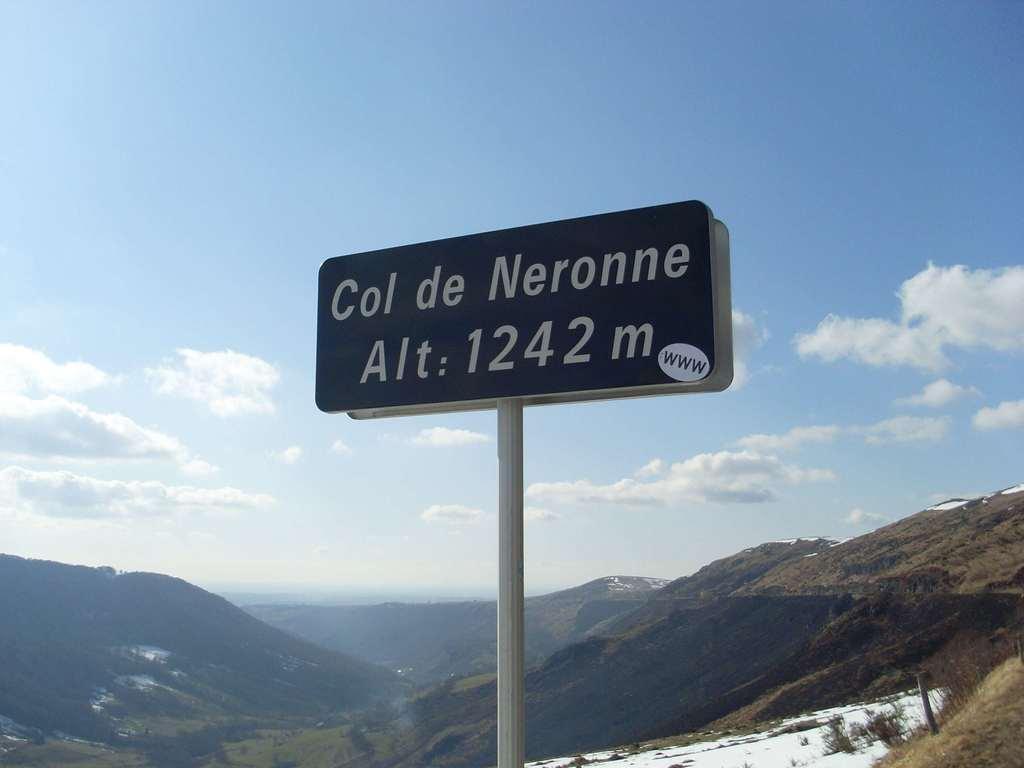Please provide a concise description of this image. In this image there is a pole in the middle. To the pole there are two boards. In the background there are hills. At the top there is the sky with the clouds. On the ground there are trees and grass. 